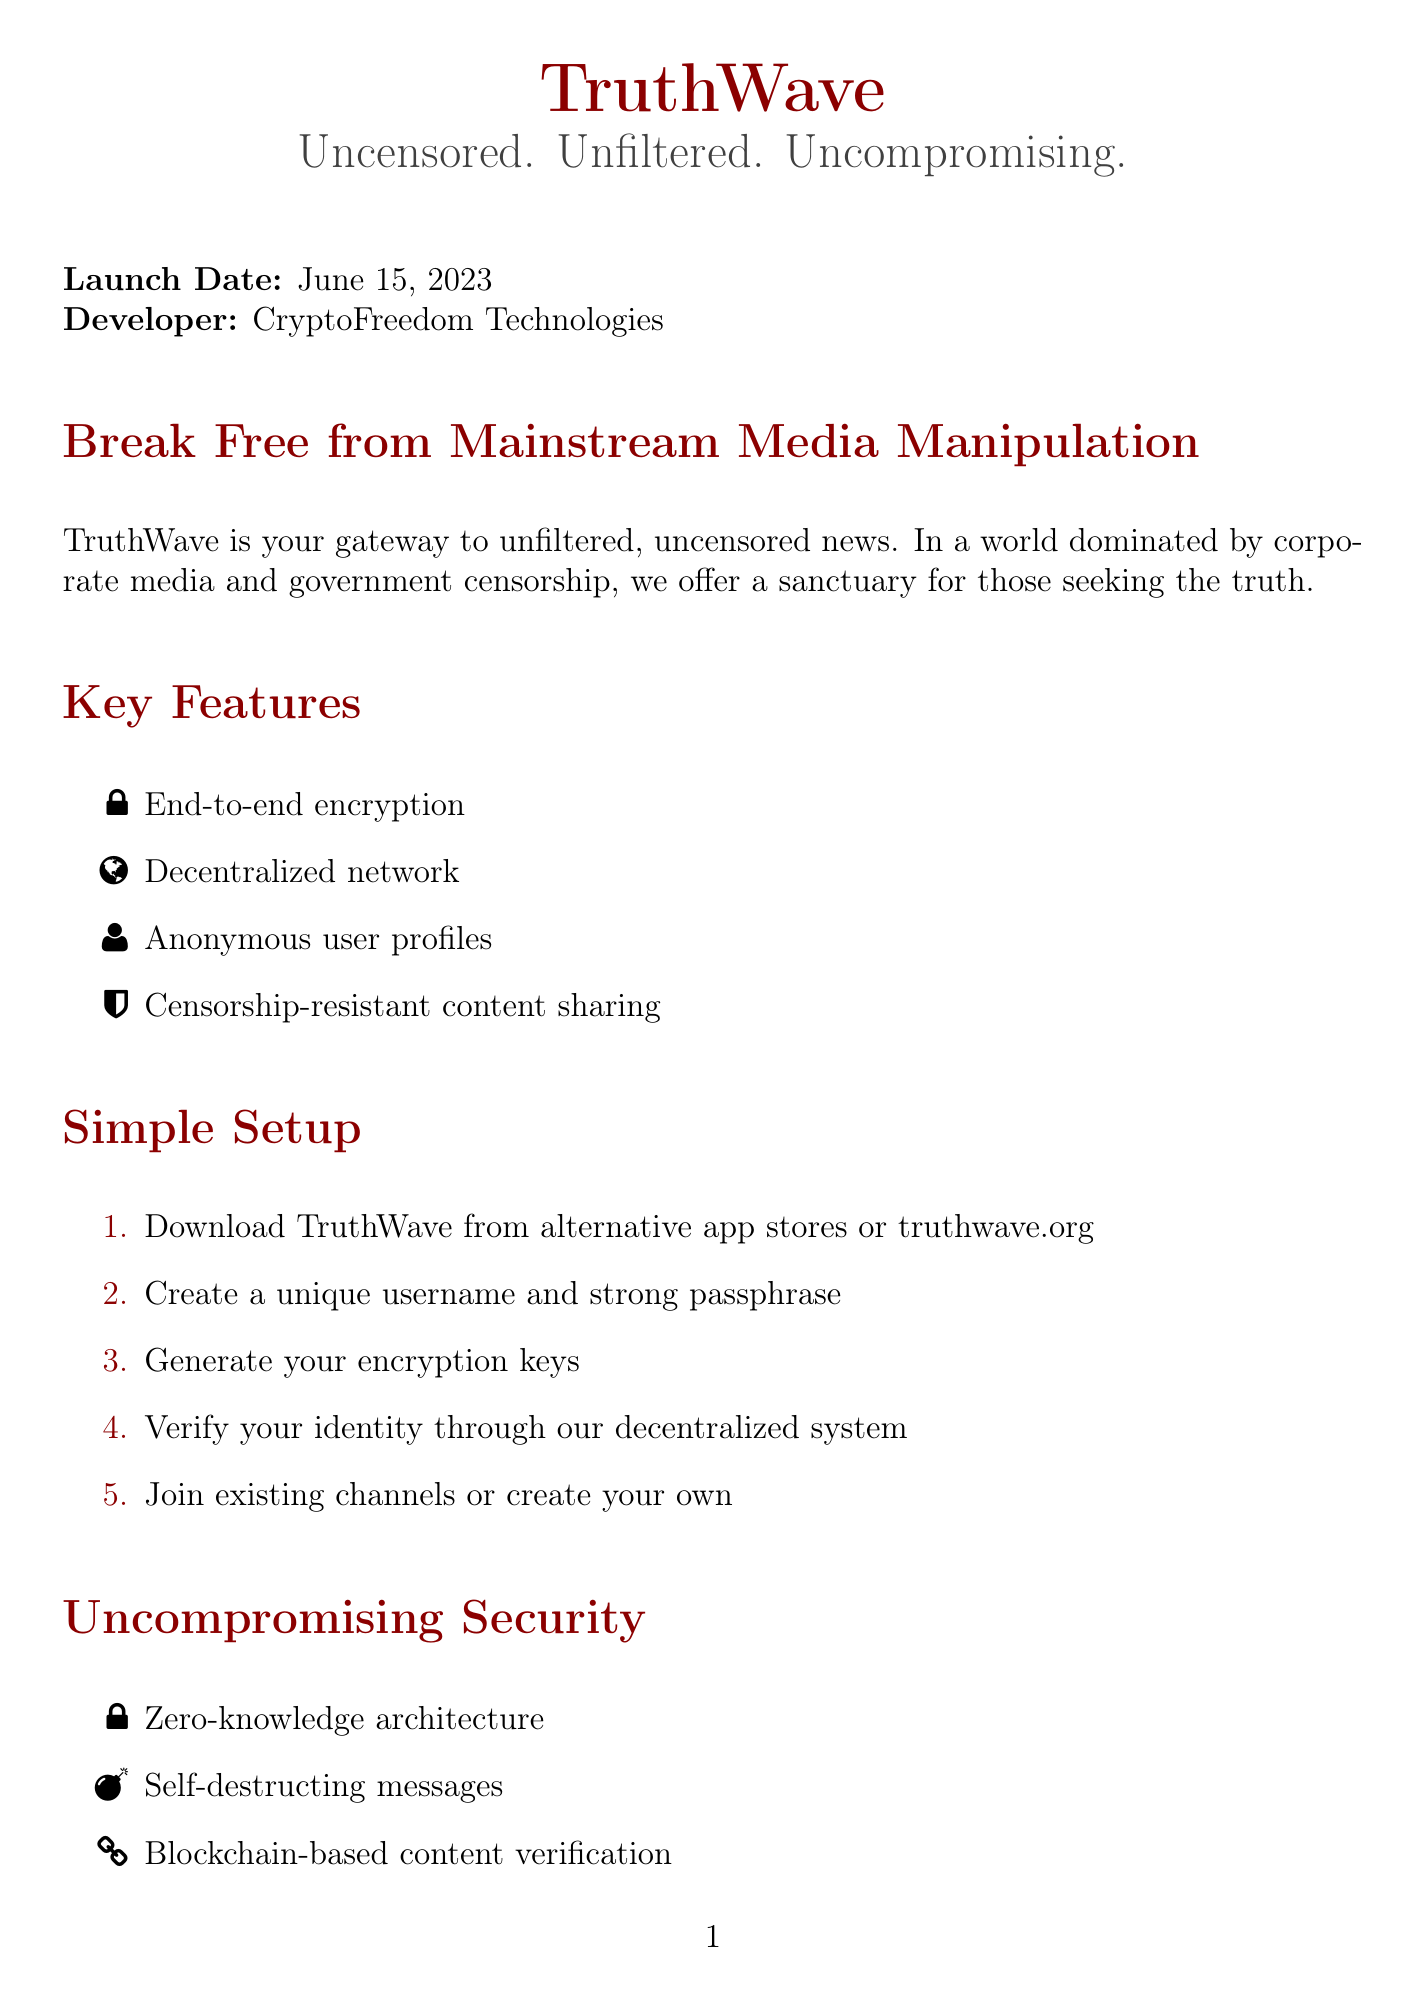What is the name of the app? The app is referred to as "TruthWave" in the document.
Answer: TruthWave When was TruthWave launched? The document states that TruthWave was launched on June 15, 2023.
Answer: June 15, 2023 Who developed TruthWave? The developer indicated in the document is "CryptoFreedom Technologies."
Answer: CryptoFreedom Technologies What type of encryption does TruthWave use? The document highlights "End-to-end encryption" as one of the main features of TruthWave.
Answer: End-to-end encryption What is one of the potential risks mentioned? The document lists "Increased exposure to unverified information" as a potential risk.
Answer: Increased exposure to unverified information What system is used for identity verification? According to the document, a "decentralized proof-of-personhood system" is used for verification.
Answer: Decentralized proof-of-personhood system Name one feature that enhances anonymity. The document mentions "VPN integration for enhanced anonymity" as a feature.
Answer: VPN integration What do testimonials claim about TruthWave? The testimonials express that TruthWave 'revolutionizes' and 'prioritizes privacy' in sharing information.
Answer: Revolutionizes and prioritizes privacy What is one community aspect highlighted in the document? The document lists "User-moderated discussion forums" as a community aspect of TruthWave.
Answer: User-moderated discussion forums 